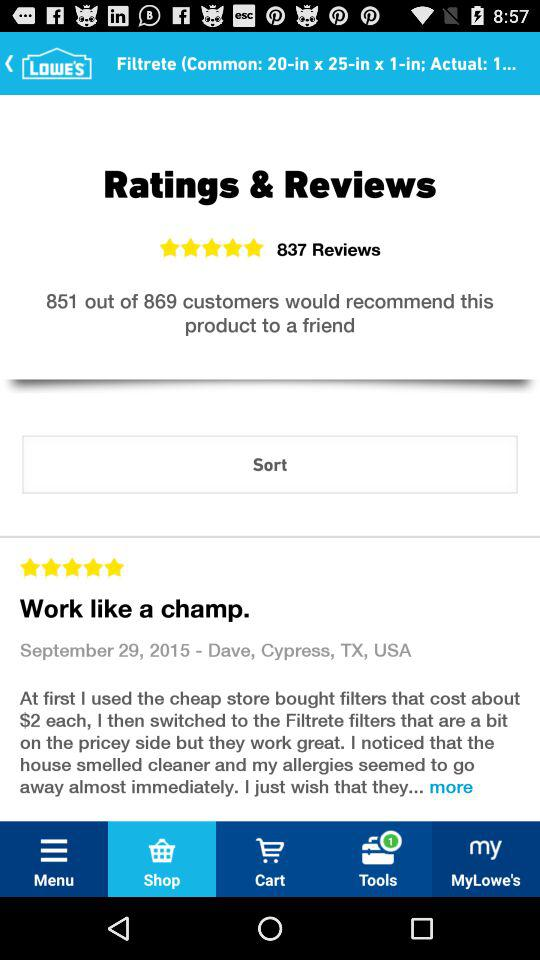On what date was the review posted? The review was posted on September 29, 2015. 